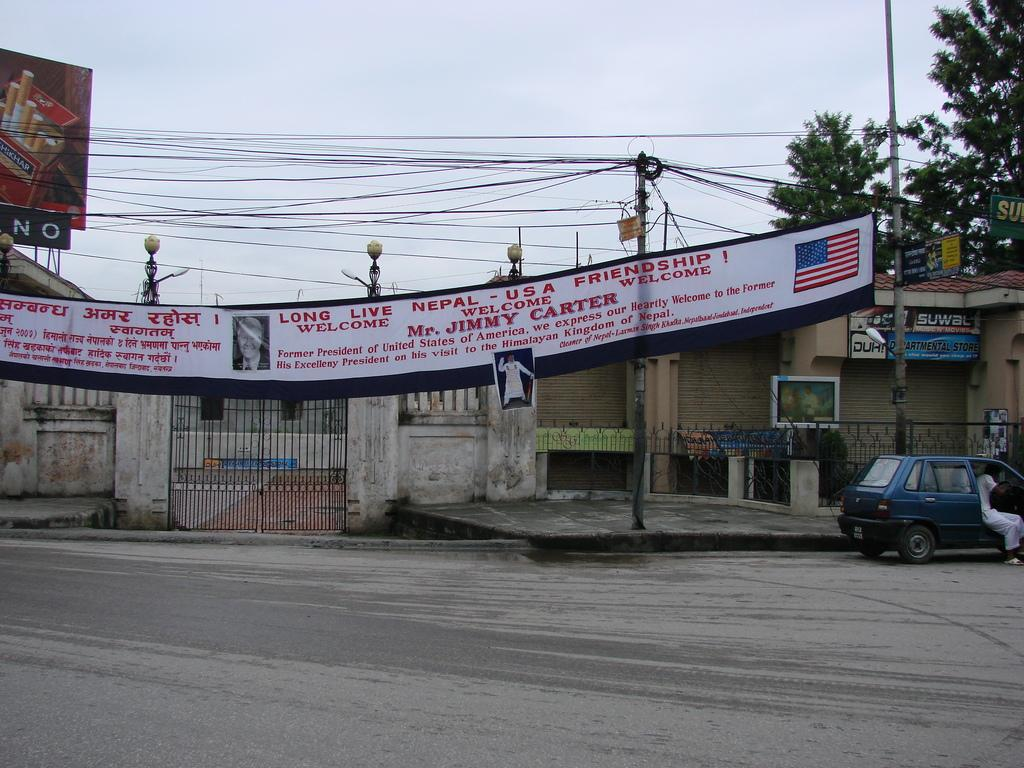What is the main feature of the image? There is a road in the image. What else can be seen on the road? Vehicles are visible in the image. Are there any decorations or signs along the road? Banners and boards are present in the image. What type of lighting is visible in the image? Lights are visible in the image. What structures support the lights and banners? Poles are present in the image. Are there any wires visible in the image? Wires are visible in the image. What is visible in the background of the image? The sky is visible in the image. Can you tell me how many hands are holding the governor's hand in the image? There is no governor or hands present in the image. What type of exchange is taking place between the governor and the people in the image? There is no governor or exchange present in the image. 